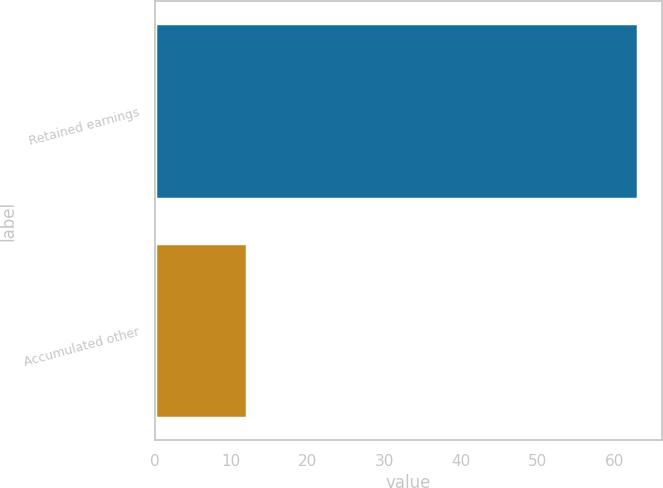Convert chart. <chart><loc_0><loc_0><loc_500><loc_500><bar_chart><fcel>Retained earnings<fcel>Accumulated other<nl><fcel>63<fcel>12<nl></chart> 